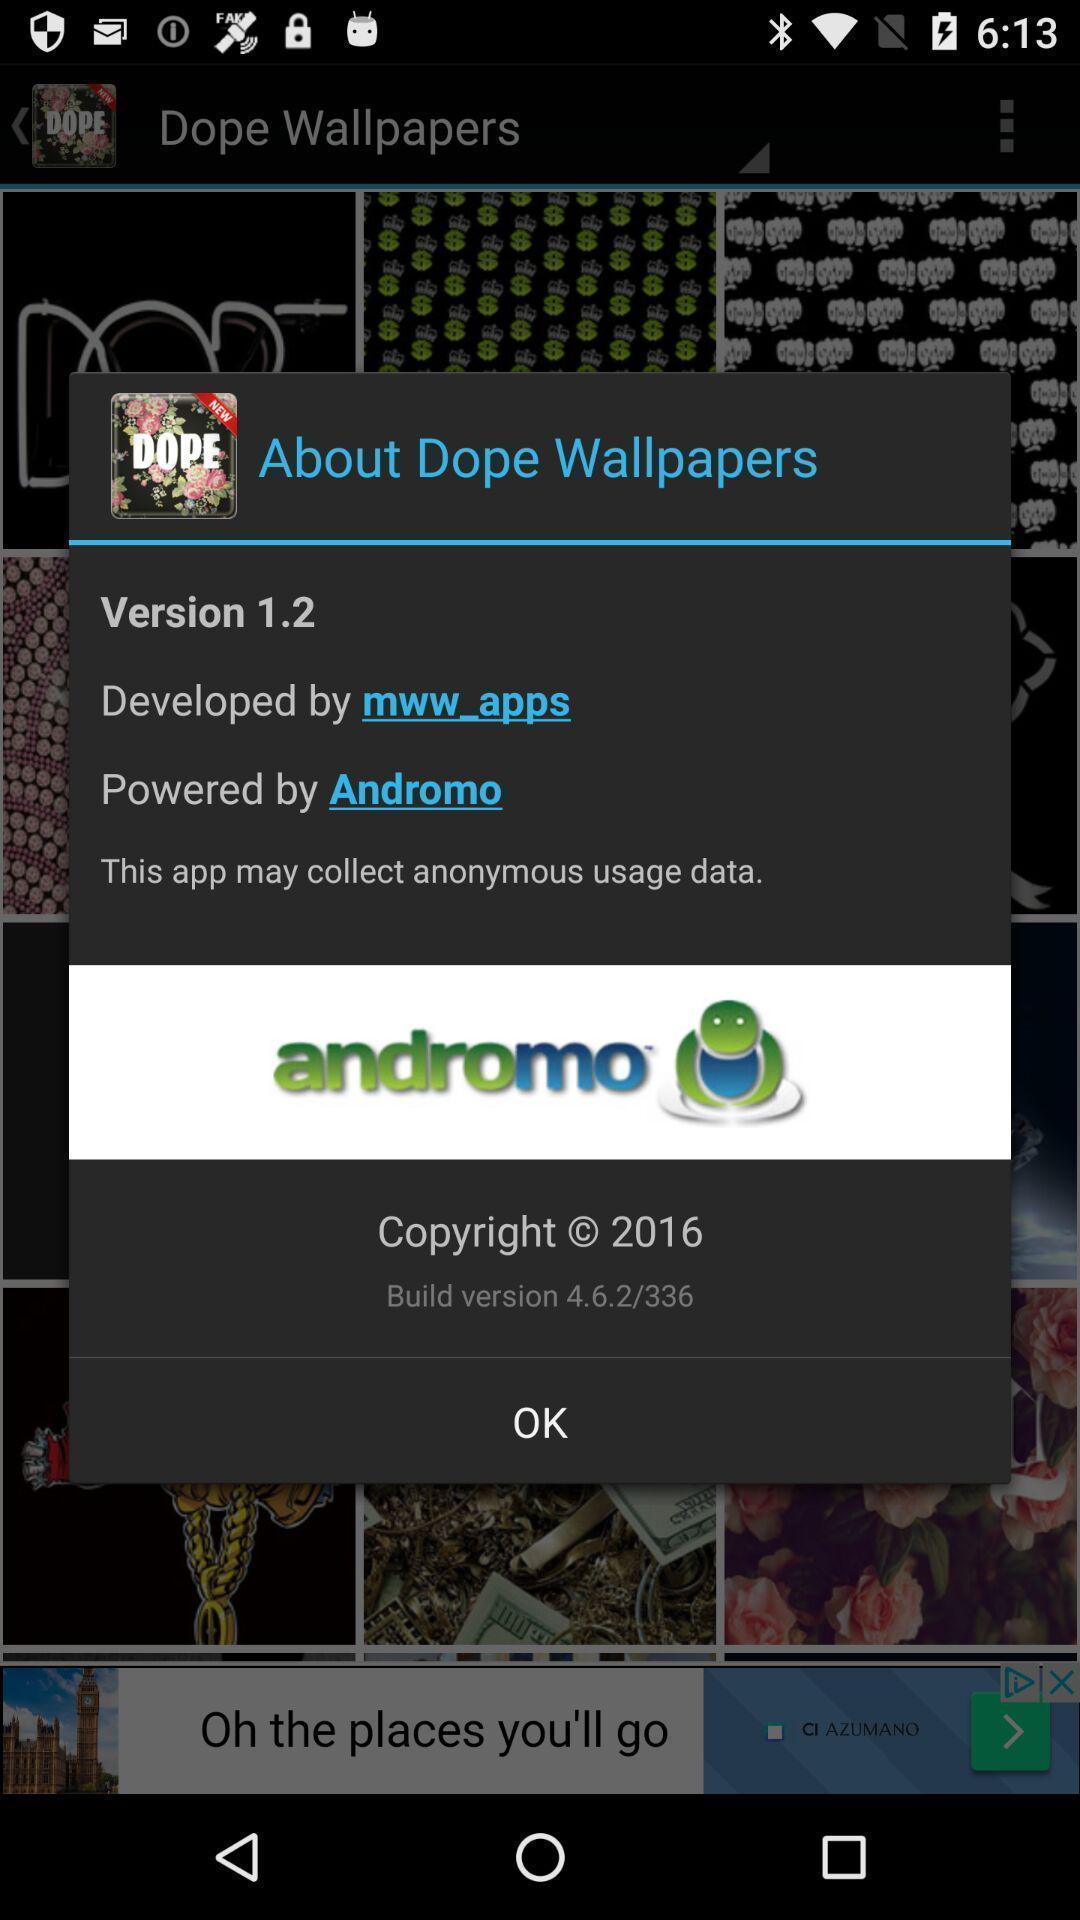Describe the key features of this screenshot. Pop-up shows about dope wallpapers. 